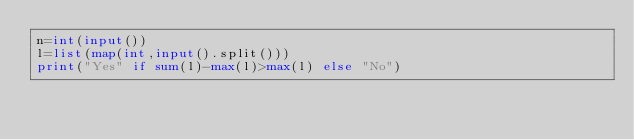<code> <loc_0><loc_0><loc_500><loc_500><_Python_>n=int(input())
l=list(map(int,input().split()))
print("Yes" if sum(l)-max(l)>max(l) else "No")</code> 